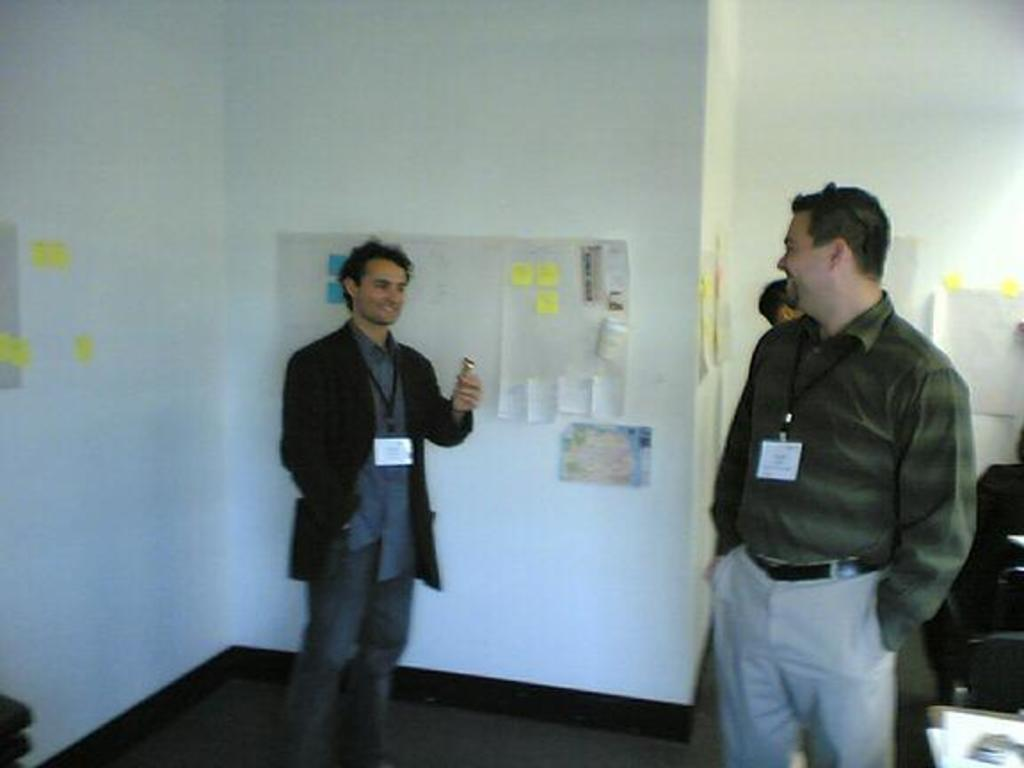What is on the wall in the background of the image? There are papers and sticky notes on the wall in the background. What are the people in the image doing? The people are standing on the floor. What type of yarn is being used by the doctor in the image? There is no doctor or yarn present in the image. What kind of music can be heard playing in the background of the image? There is no music present in the image. 